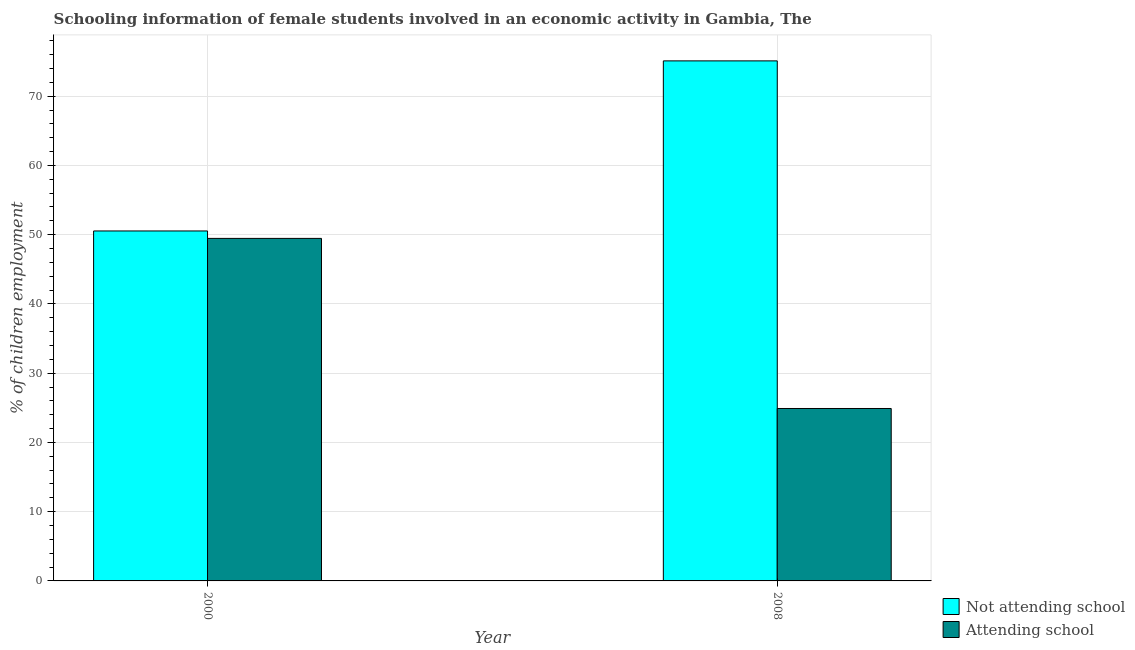How many groups of bars are there?
Your answer should be very brief. 2. What is the label of the 1st group of bars from the left?
Provide a short and direct response. 2000. In how many cases, is the number of bars for a given year not equal to the number of legend labels?
Keep it short and to the point. 0. What is the percentage of employed females who are not attending school in 2008?
Your response must be concise. 75.1. Across all years, what is the maximum percentage of employed females who are attending school?
Give a very brief answer. 49.46. Across all years, what is the minimum percentage of employed females who are not attending school?
Provide a succinct answer. 50.54. In which year was the percentage of employed females who are attending school minimum?
Your response must be concise. 2008. What is the total percentage of employed females who are not attending school in the graph?
Your answer should be very brief. 125.64. What is the difference between the percentage of employed females who are attending school in 2000 and that in 2008?
Your response must be concise. 24.56. What is the difference between the percentage of employed females who are attending school in 2008 and the percentage of employed females who are not attending school in 2000?
Give a very brief answer. -24.56. What is the average percentage of employed females who are attending school per year?
Provide a succinct answer. 37.18. In the year 2000, what is the difference between the percentage of employed females who are not attending school and percentage of employed females who are attending school?
Provide a short and direct response. 0. In how many years, is the percentage of employed females who are attending school greater than 52 %?
Offer a very short reply. 0. What is the ratio of the percentage of employed females who are not attending school in 2000 to that in 2008?
Your answer should be compact. 0.67. Is the percentage of employed females who are attending school in 2000 less than that in 2008?
Your answer should be very brief. No. In how many years, is the percentage of employed females who are attending school greater than the average percentage of employed females who are attending school taken over all years?
Offer a terse response. 1. What does the 2nd bar from the left in 2000 represents?
Provide a succinct answer. Attending school. What does the 1st bar from the right in 2008 represents?
Your response must be concise. Attending school. How many bars are there?
Your answer should be compact. 4. What is the difference between two consecutive major ticks on the Y-axis?
Offer a terse response. 10. Does the graph contain grids?
Give a very brief answer. Yes. How many legend labels are there?
Provide a succinct answer. 2. What is the title of the graph?
Your response must be concise. Schooling information of female students involved in an economic activity in Gambia, The. Does "Methane" appear as one of the legend labels in the graph?
Offer a very short reply. No. What is the label or title of the X-axis?
Offer a terse response. Year. What is the label or title of the Y-axis?
Your response must be concise. % of children employment. What is the % of children employment in Not attending school in 2000?
Give a very brief answer. 50.54. What is the % of children employment of Attending school in 2000?
Keep it short and to the point. 49.46. What is the % of children employment in Not attending school in 2008?
Keep it short and to the point. 75.1. What is the % of children employment in Attending school in 2008?
Give a very brief answer. 24.9. Across all years, what is the maximum % of children employment of Not attending school?
Provide a succinct answer. 75.1. Across all years, what is the maximum % of children employment in Attending school?
Offer a terse response. 49.46. Across all years, what is the minimum % of children employment of Not attending school?
Give a very brief answer. 50.54. Across all years, what is the minimum % of children employment of Attending school?
Ensure brevity in your answer.  24.9. What is the total % of children employment of Not attending school in the graph?
Provide a short and direct response. 125.64. What is the total % of children employment in Attending school in the graph?
Give a very brief answer. 74.36. What is the difference between the % of children employment in Not attending school in 2000 and that in 2008?
Make the answer very short. -24.56. What is the difference between the % of children employment in Attending school in 2000 and that in 2008?
Your answer should be very brief. 24.56. What is the difference between the % of children employment of Not attending school in 2000 and the % of children employment of Attending school in 2008?
Ensure brevity in your answer.  25.64. What is the average % of children employment in Not attending school per year?
Keep it short and to the point. 62.82. What is the average % of children employment of Attending school per year?
Make the answer very short. 37.18. In the year 2000, what is the difference between the % of children employment in Not attending school and % of children employment in Attending school?
Provide a short and direct response. 1.07. In the year 2008, what is the difference between the % of children employment of Not attending school and % of children employment of Attending school?
Your response must be concise. 50.2. What is the ratio of the % of children employment in Not attending school in 2000 to that in 2008?
Provide a succinct answer. 0.67. What is the ratio of the % of children employment in Attending school in 2000 to that in 2008?
Keep it short and to the point. 1.99. What is the difference between the highest and the second highest % of children employment of Not attending school?
Your answer should be very brief. 24.56. What is the difference between the highest and the second highest % of children employment in Attending school?
Provide a short and direct response. 24.56. What is the difference between the highest and the lowest % of children employment of Not attending school?
Ensure brevity in your answer.  24.56. What is the difference between the highest and the lowest % of children employment in Attending school?
Provide a succinct answer. 24.56. 